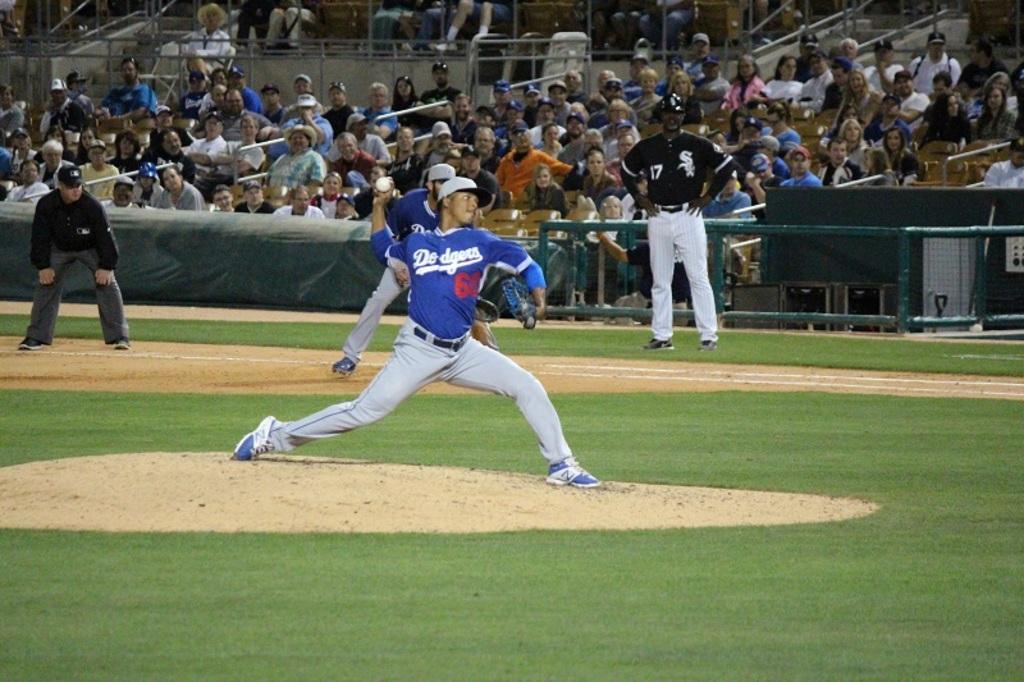In one or two sentences, can you explain what this image depicts? In the image we can see there are many people wearing clothes, these people are wearing a cap and shoes. This is a ground and there are people sitting. This is a fence, ball, grass, sand, white lines and an object. 